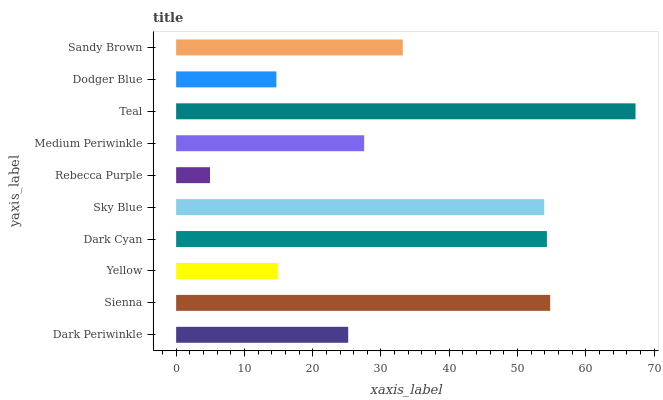Is Rebecca Purple the minimum?
Answer yes or no. Yes. Is Teal the maximum?
Answer yes or no. Yes. Is Sienna the minimum?
Answer yes or no. No. Is Sienna the maximum?
Answer yes or no. No. Is Sienna greater than Dark Periwinkle?
Answer yes or no. Yes. Is Dark Periwinkle less than Sienna?
Answer yes or no. Yes. Is Dark Periwinkle greater than Sienna?
Answer yes or no. No. Is Sienna less than Dark Periwinkle?
Answer yes or no. No. Is Sandy Brown the high median?
Answer yes or no. Yes. Is Medium Periwinkle the low median?
Answer yes or no. Yes. Is Medium Periwinkle the high median?
Answer yes or no. No. Is Sandy Brown the low median?
Answer yes or no. No. 